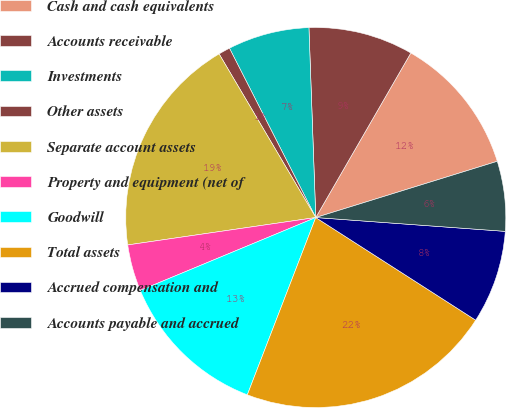Convert chart to OTSL. <chart><loc_0><loc_0><loc_500><loc_500><pie_chart><fcel>Cash and cash equivalents<fcel>Accounts receivable<fcel>Investments<fcel>Other assets<fcel>Separate account assets<fcel>Property and equipment (net of<fcel>Goodwill<fcel>Total assets<fcel>Accrued compensation and<fcel>Accounts payable and accrued<nl><fcel>11.88%<fcel>8.91%<fcel>6.93%<fcel>0.99%<fcel>18.81%<fcel>3.96%<fcel>12.87%<fcel>21.78%<fcel>7.92%<fcel>5.94%<nl></chart> 